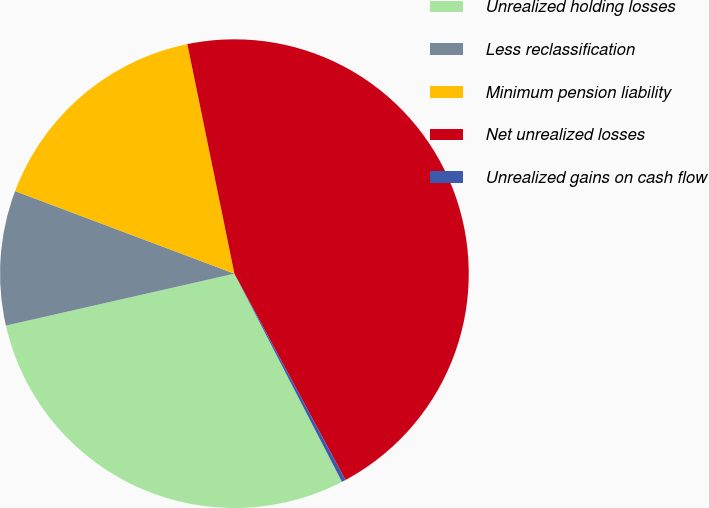<chart> <loc_0><loc_0><loc_500><loc_500><pie_chart><fcel>Unrealized holding losses<fcel>Less reclassification<fcel>Minimum pension liability<fcel>Net unrealized losses<fcel>Unrealized gains on cash flow<nl><fcel>29.03%<fcel>9.29%<fcel>16.05%<fcel>45.36%<fcel>0.27%<nl></chart> 